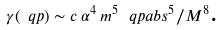<formula> <loc_0><loc_0><loc_500><loc_500>\gamma ( \ q p ) \sim c \, \alpha ^ { 4 } \, m ^ { 5 } \, \ q p a b s ^ { 5 } / M ^ { 8 } \text  .</formula> 